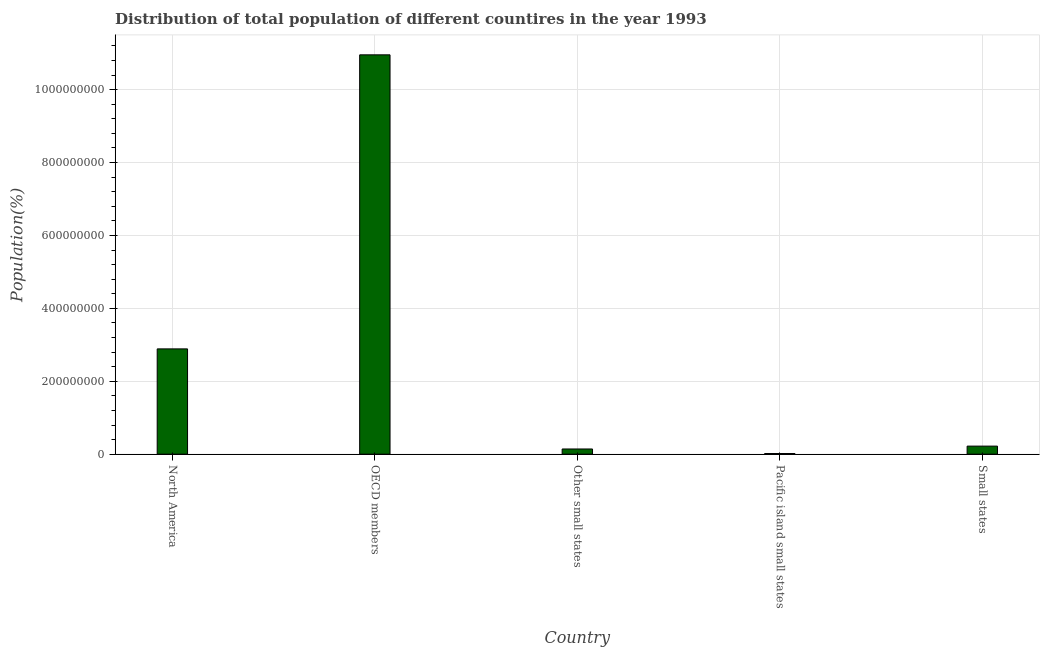Does the graph contain grids?
Your answer should be compact. Yes. What is the title of the graph?
Your answer should be very brief. Distribution of total population of different countires in the year 1993. What is the label or title of the X-axis?
Your answer should be compact. Country. What is the label or title of the Y-axis?
Offer a terse response. Population(%). What is the population in Pacific island small states?
Ensure brevity in your answer.  1.77e+06. Across all countries, what is the maximum population?
Give a very brief answer. 1.10e+09. Across all countries, what is the minimum population?
Keep it short and to the point. 1.77e+06. In which country was the population maximum?
Provide a short and direct response. OECD members. In which country was the population minimum?
Offer a terse response. Pacific island small states. What is the sum of the population?
Ensure brevity in your answer.  1.42e+09. What is the difference between the population in Other small states and Small states?
Keep it short and to the point. -7.87e+06. What is the average population per country?
Provide a succinct answer. 2.84e+08. What is the median population?
Give a very brief answer. 2.21e+07. What is the ratio of the population in OECD members to that in Pacific island small states?
Provide a short and direct response. 618.13. What is the difference between the highest and the second highest population?
Offer a very short reply. 8.07e+08. Is the sum of the population in Pacific island small states and Small states greater than the maximum population across all countries?
Give a very brief answer. No. What is the difference between the highest and the lowest population?
Provide a succinct answer. 1.09e+09. In how many countries, is the population greater than the average population taken over all countries?
Ensure brevity in your answer.  2. Are all the bars in the graph horizontal?
Provide a succinct answer. No. What is the difference between two consecutive major ticks on the Y-axis?
Provide a succinct answer. 2.00e+08. Are the values on the major ticks of Y-axis written in scientific E-notation?
Keep it short and to the point. No. What is the Population(%) of North America?
Provide a succinct answer. 2.89e+08. What is the Population(%) in OECD members?
Provide a succinct answer. 1.10e+09. What is the Population(%) of Other small states?
Make the answer very short. 1.42e+07. What is the Population(%) in Pacific island small states?
Your response must be concise. 1.77e+06. What is the Population(%) in Small states?
Your answer should be compact. 2.21e+07. What is the difference between the Population(%) in North America and OECD members?
Your response must be concise. -8.07e+08. What is the difference between the Population(%) in North America and Other small states?
Offer a very short reply. 2.75e+08. What is the difference between the Population(%) in North America and Pacific island small states?
Provide a succinct answer. 2.87e+08. What is the difference between the Population(%) in North America and Small states?
Make the answer very short. 2.67e+08. What is the difference between the Population(%) in OECD members and Other small states?
Ensure brevity in your answer.  1.08e+09. What is the difference between the Population(%) in OECD members and Pacific island small states?
Your answer should be very brief. 1.09e+09. What is the difference between the Population(%) in OECD members and Small states?
Your answer should be very brief. 1.07e+09. What is the difference between the Population(%) in Other small states and Pacific island small states?
Keep it short and to the point. 1.24e+07. What is the difference between the Population(%) in Other small states and Small states?
Offer a terse response. -7.87e+06. What is the difference between the Population(%) in Pacific island small states and Small states?
Provide a succinct answer. -2.03e+07. What is the ratio of the Population(%) in North America to that in OECD members?
Keep it short and to the point. 0.26. What is the ratio of the Population(%) in North America to that in Other small states?
Provide a succinct answer. 20.32. What is the ratio of the Population(%) in North America to that in Pacific island small states?
Ensure brevity in your answer.  162.96. What is the ratio of the Population(%) in North America to that in Small states?
Offer a terse response. 13.08. What is the ratio of the Population(%) in OECD members to that in Other small states?
Offer a terse response. 77.09. What is the ratio of the Population(%) in OECD members to that in Pacific island small states?
Provide a short and direct response. 618.13. What is the ratio of the Population(%) in OECD members to that in Small states?
Ensure brevity in your answer.  49.62. What is the ratio of the Population(%) in Other small states to that in Pacific island small states?
Your answer should be compact. 8.02. What is the ratio of the Population(%) in Other small states to that in Small states?
Make the answer very short. 0.64. What is the ratio of the Population(%) in Pacific island small states to that in Small states?
Keep it short and to the point. 0.08. 